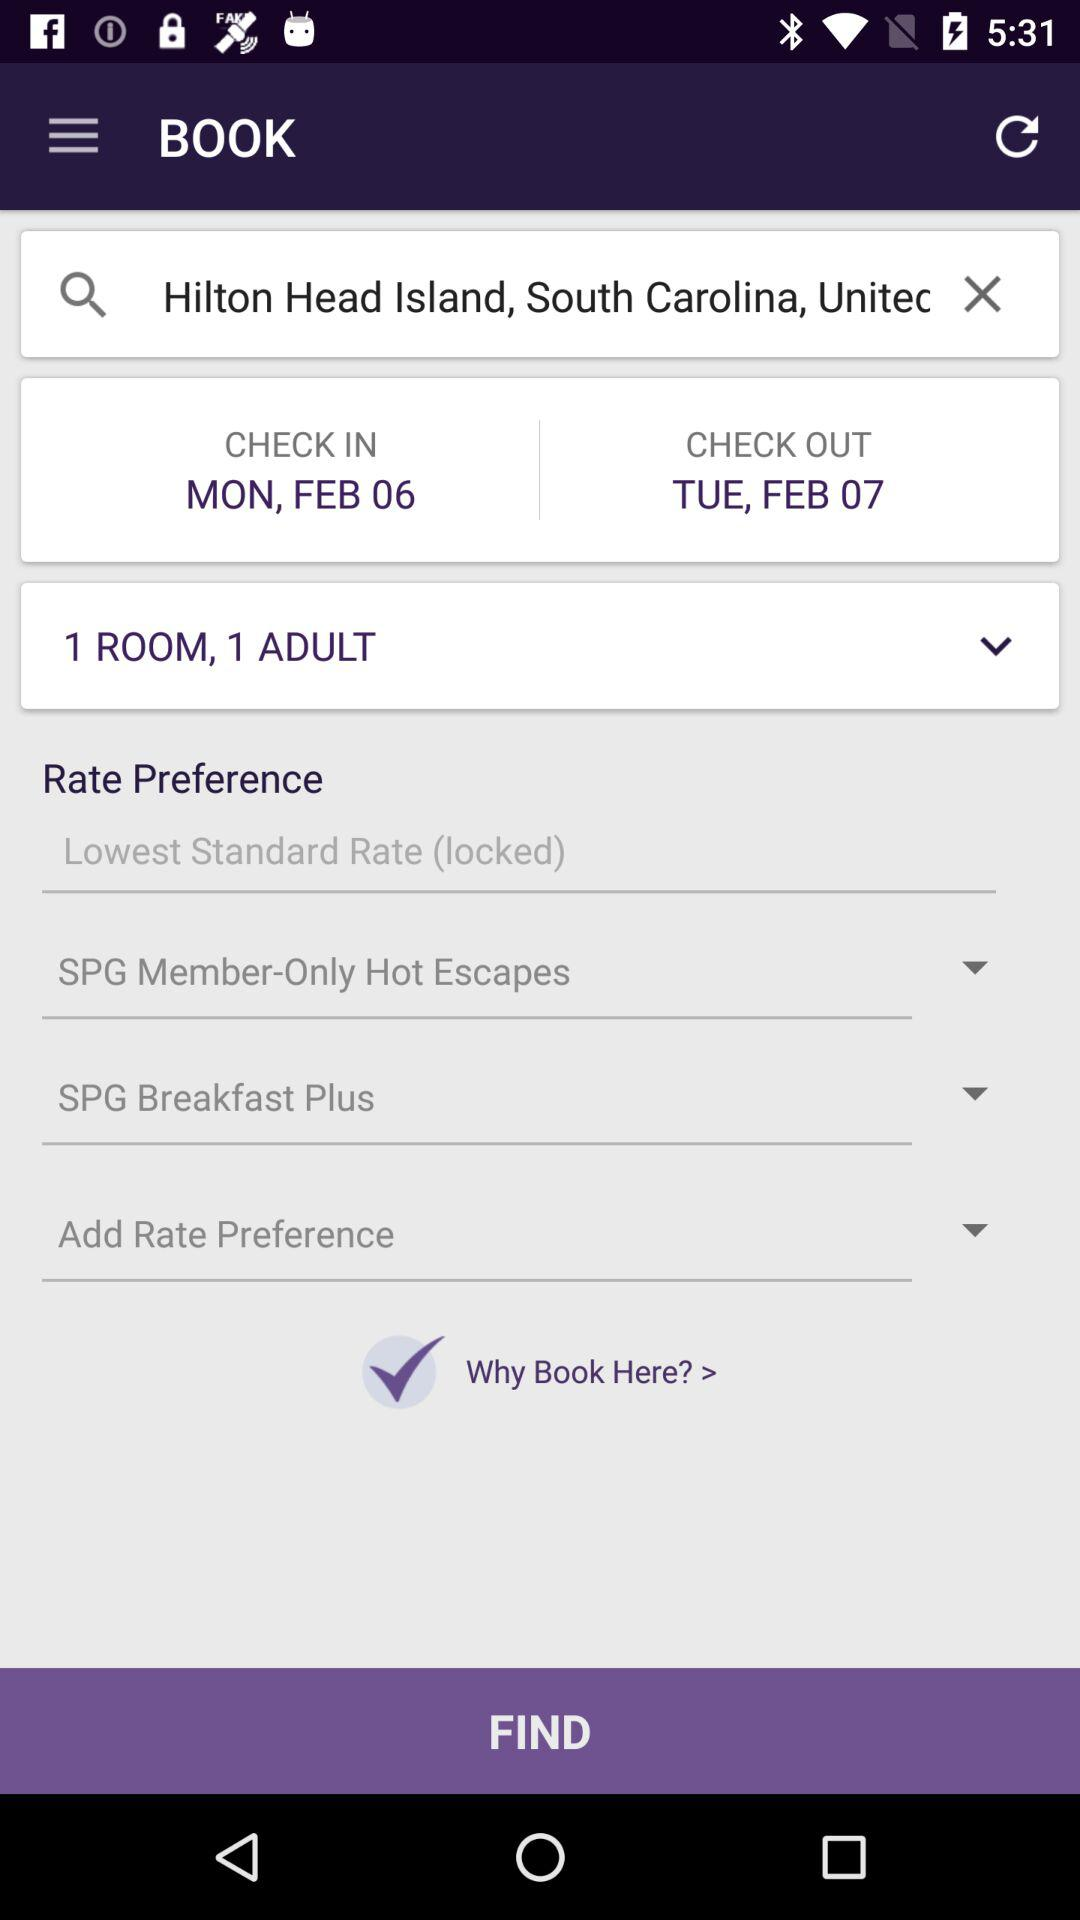How many adults will stay in one room? In one room, one adult will stay. 